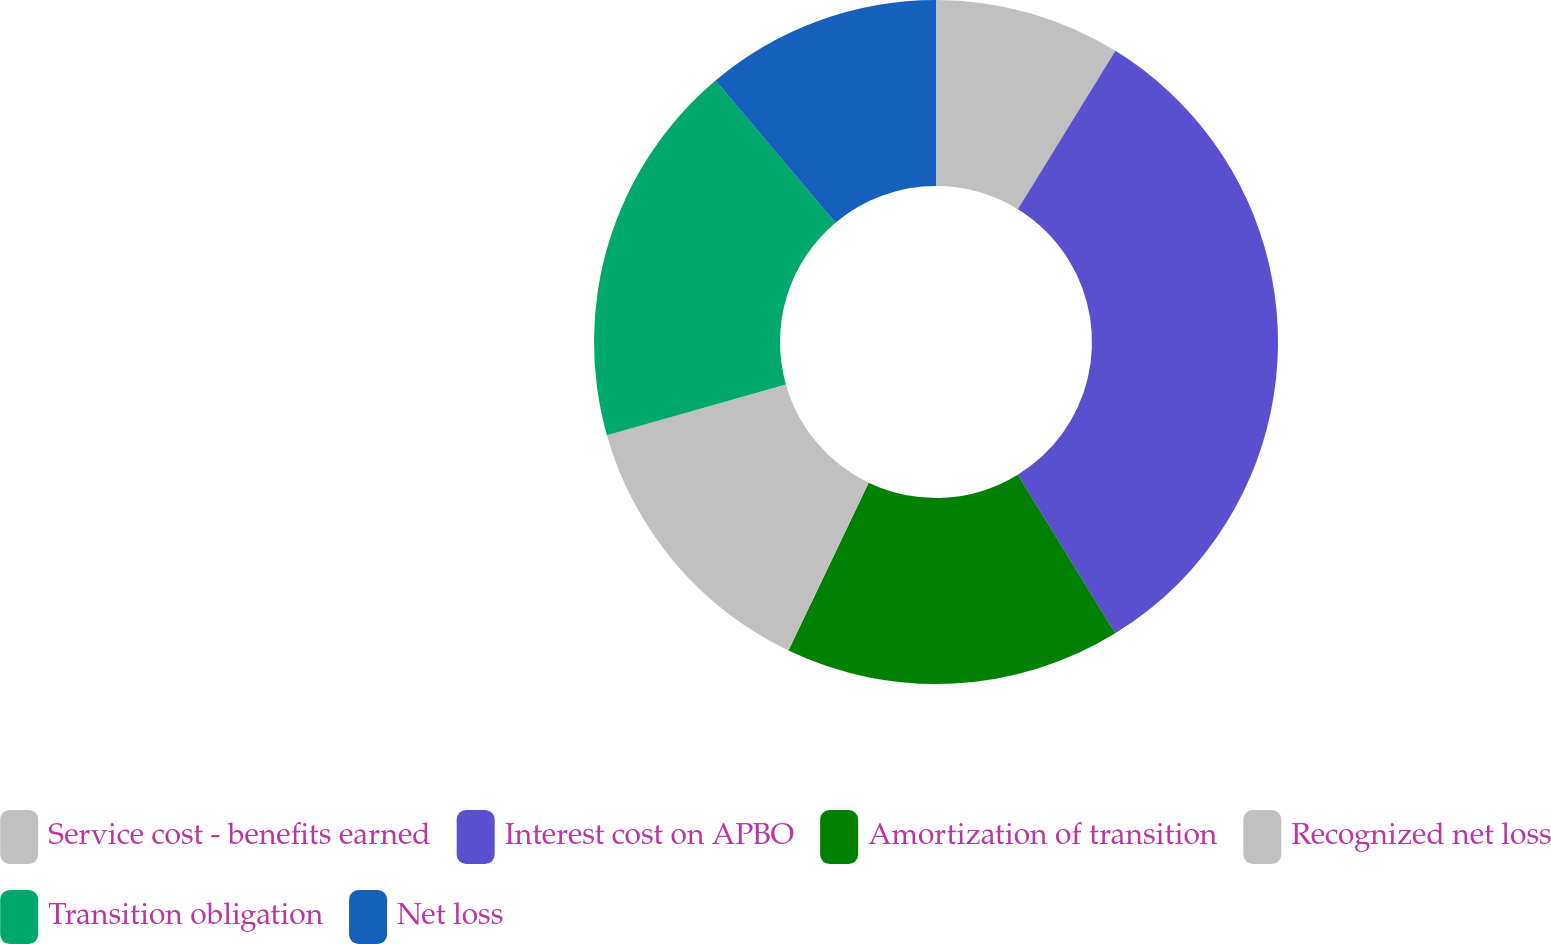Convert chart. <chart><loc_0><loc_0><loc_500><loc_500><pie_chart><fcel>Service cost - benefits earned<fcel>Interest cost on APBO<fcel>Amortization of transition<fcel>Recognized net loss<fcel>Transition obligation<fcel>Net loss<nl><fcel>8.79%<fcel>32.43%<fcel>15.88%<fcel>13.51%<fcel>18.24%<fcel>11.15%<nl></chart> 